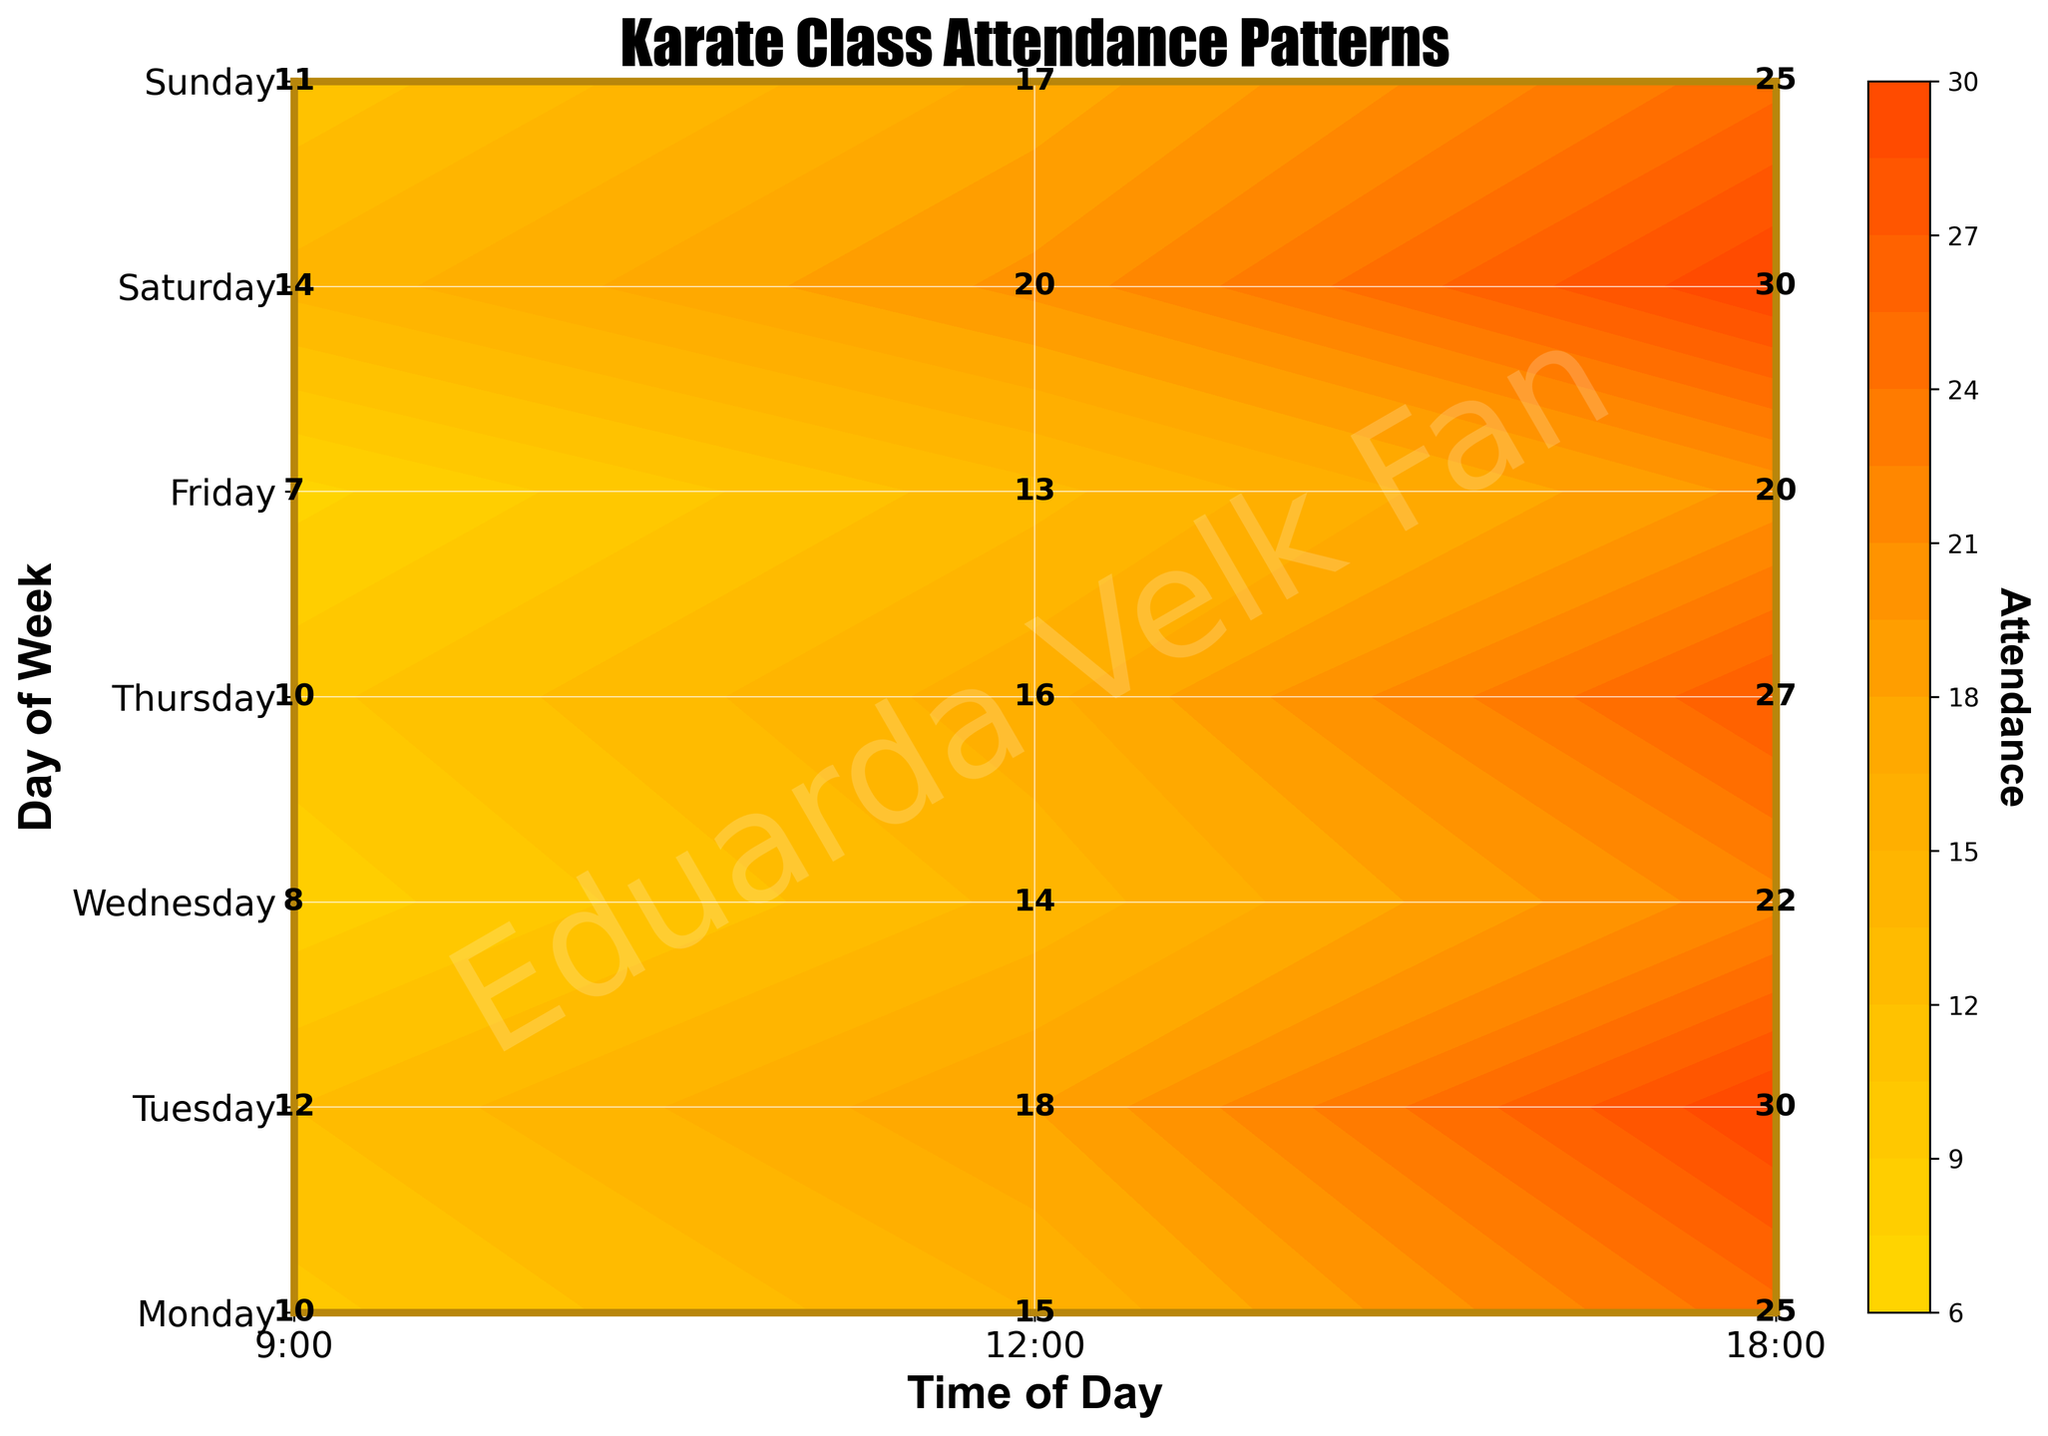What is the peak attendance time on Saturday? The peak attendance time on Saturday can be identified by looking at the highest attendance value for that day. The attendance values for Saturday are 14 at 9:00, 20 at 12:00, and 30 at 18:00. The highest attendance is 30 at 18:00.
Answer: 18:00 Which day has the lowest overall attendance? To find the day with the lowest overall attendance, sum up the attendance values for each day and compare them. The totals for each day are as follows: Monday (50), Tuesday (60), Wednesday (44), Thursday (53), Friday (40), Saturday (64), Sunday (53). The lowest overall attendance is on Friday.
Answer: Friday What is the title of the plot? The title is usually found at the top of the plot. In this case, the title is 'Karate Class Attendance Patterns'.
Answer: Karate Class Attendance Patterns Which time slot has the highest attendance across all days? To determine which time slot has the highest attendance across all days, sum up the attendance for 9:00, 12:00, and 18:00 across all seven days. The totals are: 9:00 (72), 12:00 (113), 18:00 (179). The highest attendance is at 18:00.
Answer: 18:00 What is the attendance on Tuesday at 12:00? attendance at Tuesday 12:00 can be directly read from the figure. It is given as 18.
Answer: 18 What color represents the highest attendance in the colormap? The highest attendance color is represented by the warmest color on the custom colormap, transitioning from Gold, Orange to Red-Orange. The highest attendance is associated with the Red-Orange color.
Answer: Red-Orange Which days have identical attendance patterns for all three time slots? To find days with identical attendance patterns, look for days with the same attendance values across all three time slots. None of the days listed have identical attendance values for all three time slots when compared directly.
Answer: None 